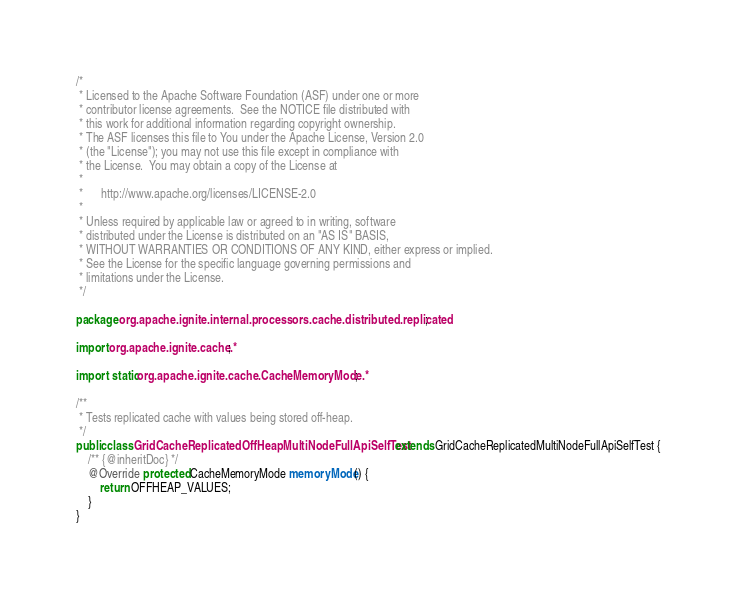<code> <loc_0><loc_0><loc_500><loc_500><_Java_>/*
 * Licensed to the Apache Software Foundation (ASF) under one or more
 * contributor license agreements.  See the NOTICE file distributed with
 * this work for additional information regarding copyright ownership.
 * The ASF licenses this file to You under the Apache License, Version 2.0
 * (the "License"); you may not use this file except in compliance with
 * the License.  You may obtain a copy of the License at
 *
 *      http://www.apache.org/licenses/LICENSE-2.0
 *
 * Unless required by applicable law or agreed to in writing, software
 * distributed under the License is distributed on an "AS IS" BASIS,
 * WITHOUT WARRANTIES OR CONDITIONS OF ANY KIND, either express or implied.
 * See the License for the specific language governing permissions and
 * limitations under the License.
 */

package org.apache.ignite.internal.processors.cache.distributed.replicated;

import org.apache.ignite.cache.*;

import static org.apache.ignite.cache.CacheMemoryMode.*;

/**
 * Tests replicated cache with values being stored off-heap.
 */
public class GridCacheReplicatedOffHeapMultiNodeFullApiSelfTest extends GridCacheReplicatedMultiNodeFullApiSelfTest {
    /** {@inheritDoc} */
    @Override protected CacheMemoryMode memoryMode() {
        return OFFHEAP_VALUES;
    }
}
</code> 